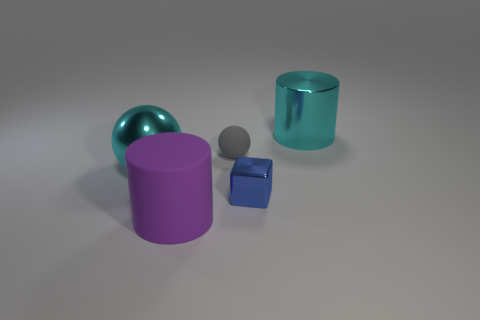Is the number of big purple rubber cylinders that are behind the big metal ball greater than the number of spheres in front of the small blue thing?
Your answer should be very brief. No. There is a object that is the same color as the big ball; what is its size?
Provide a short and direct response. Large. Is the size of the purple matte cylinder the same as the cyan thing in front of the tiny rubber object?
Your response must be concise. Yes. How many cubes are either brown matte things or large purple rubber things?
Your answer should be very brief. 0. What is the size of the purple cylinder that is made of the same material as the small gray sphere?
Make the answer very short. Large. There is a cyan shiny object that is in front of the tiny gray matte sphere; does it have the same size as the rubber object behind the large purple rubber cylinder?
Provide a short and direct response. No. How many things are small purple rubber cubes or blue objects?
Offer a very short reply. 1. What is the shape of the tiny blue shiny object?
Your response must be concise. Cube. The cyan object that is the same shape as the purple rubber thing is what size?
Make the answer very short. Large. Is there anything else that has the same material as the blue block?
Provide a succinct answer. Yes. 